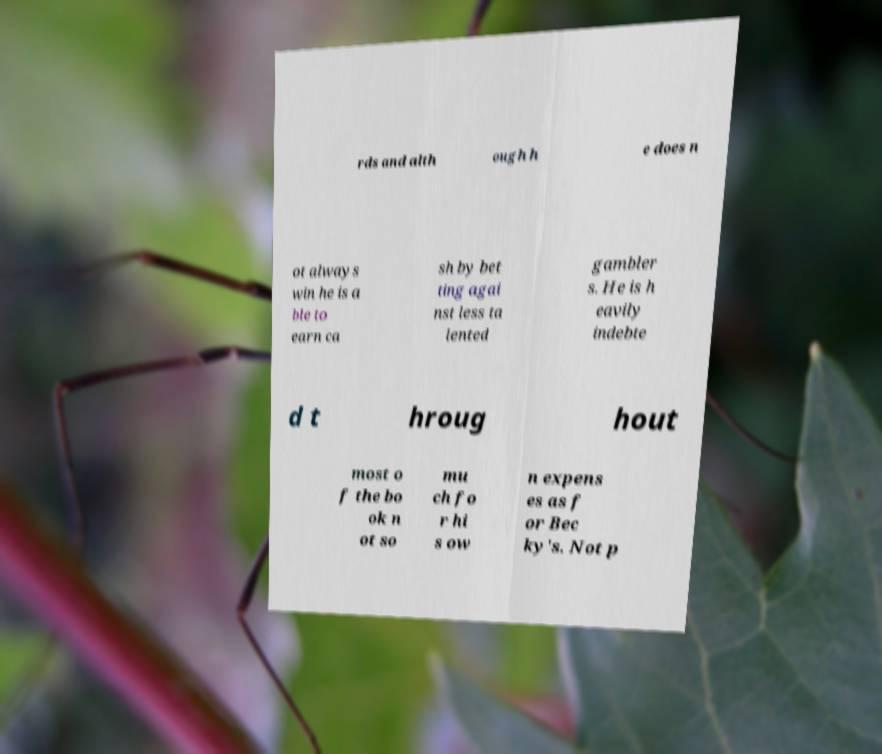Could you extract and type out the text from this image? rds and alth ough h e does n ot always win he is a ble to earn ca sh by bet ting agai nst less ta lented gambler s. He is h eavily indebte d t hroug hout most o f the bo ok n ot so mu ch fo r hi s ow n expens es as f or Bec ky's. Not p 